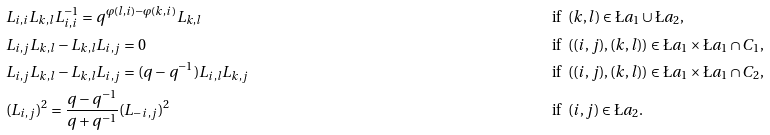<formula> <loc_0><loc_0><loc_500><loc_500>& L _ { i , i } L _ { k , l } L _ { i , i } ^ { - 1 } = q ^ { \varphi ( l , i ) - \varphi ( k , i ) } L _ { k , l } & & \text {if} \ \ ( k , l ) \in \L a _ { 1 } \cup \L a _ { 2 } , \\ & L _ { i , j } L _ { k , l } - L _ { k , l } L _ { i , j } = 0 \quad & & \text {if} \ \ ( ( i , j ) , ( k , l ) ) \in \L a _ { 1 } \times \L a _ { 1 } \cap C _ { 1 } , \\ & L _ { i , j } L _ { k , l } - L _ { k , l } L _ { i , j } = ( q - q ^ { - 1 } ) L _ { i , l } L _ { k , j } \quad & & \text {if} \ \ ( ( i , j ) , ( k , l ) ) \in \L a _ { 1 } \times \L a _ { 1 } \cap C _ { 2 } , \\ & ( L _ { i , j } ) ^ { 2 } = \frac { q - q ^ { - 1 } } { q + q ^ { - 1 } } ( L _ { - i , j } ) ^ { 2 } \ \ & & \text {if} \ \ ( i , j ) \in \L a _ { 2 } .</formula> 